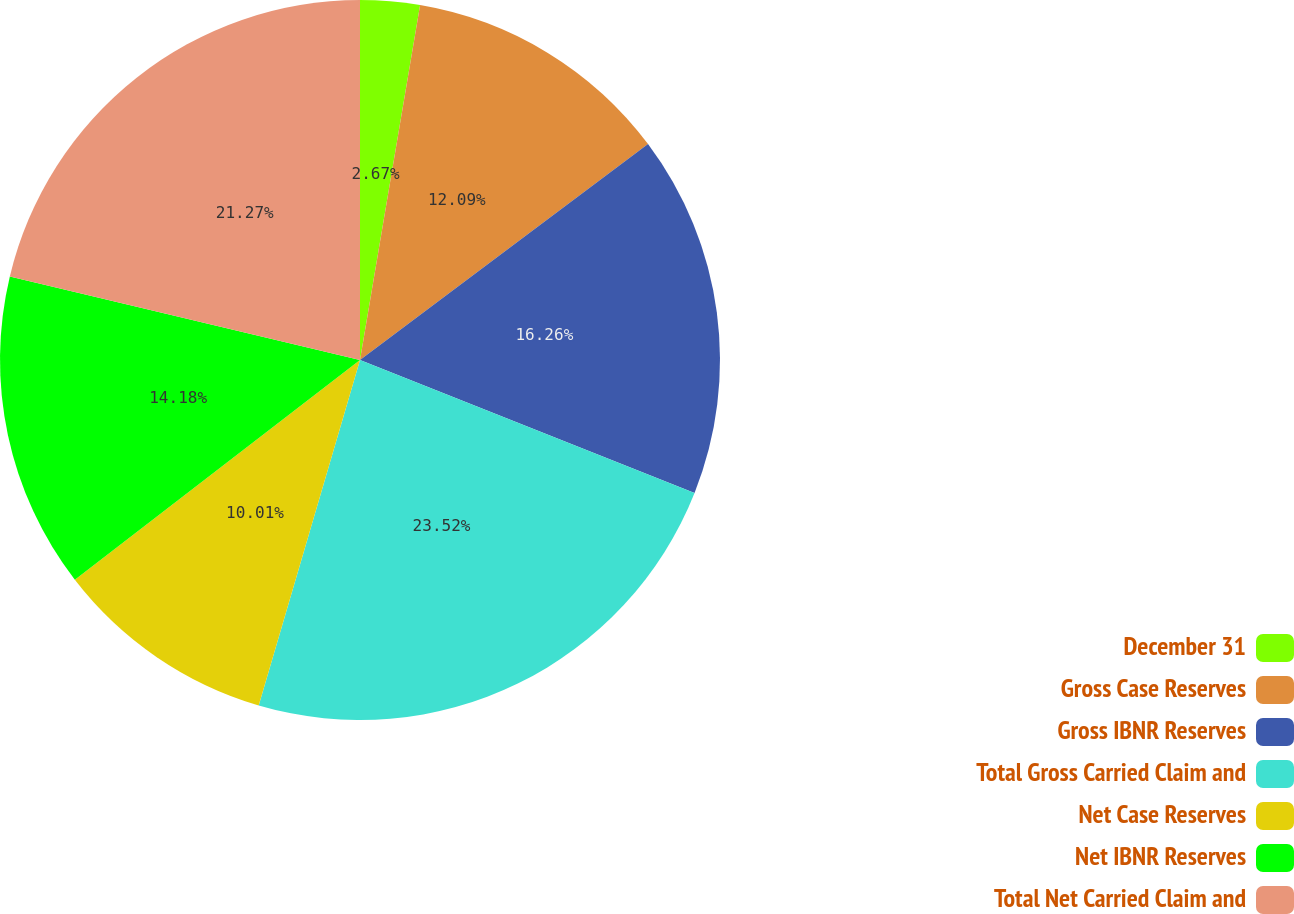Convert chart to OTSL. <chart><loc_0><loc_0><loc_500><loc_500><pie_chart><fcel>December 31<fcel>Gross Case Reserves<fcel>Gross IBNR Reserves<fcel>Total Gross Carried Claim and<fcel>Net Case Reserves<fcel>Net IBNR Reserves<fcel>Total Net Carried Claim and<nl><fcel>2.67%<fcel>12.09%<fcel>16.26%<fcel>23.52%<fcel>10.01%<fcel>14.18%<fcel>21.27%<nl></chart> 